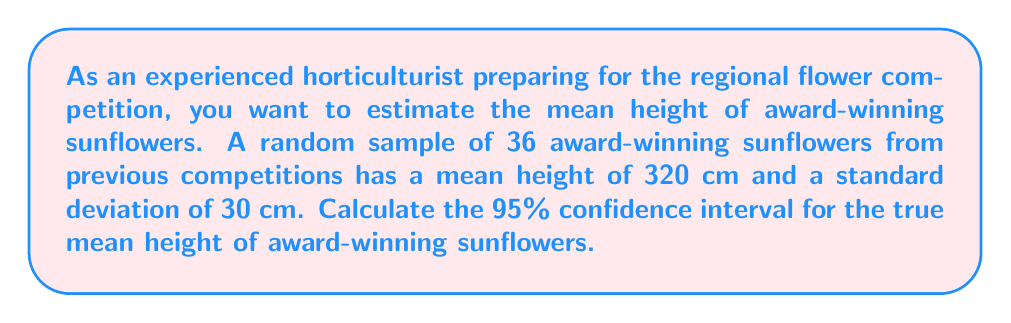What is the answer to this math problem? Let's calculate the confidence interval step-by-step:

1) The formula for the confidence interval is:

   $$\bar{x} \pm t_{\alpha/2} \cdot \frac{s}{\sqrt{n}}$$

   where $\bar{x}$ is the sample mean, $s$ is the sample standard deviation, $n$ is the sample size, and $t_{\alpha/2}$ is the t-value for the desired confidence level.

2) We know:
   - $\bar{x} = 320$ cm
   - $s = 30$ cm
   - $n = 36$
   - Confidence level = 95%, so $\alpha = 0.05$

3) For a 95% confidence interval with 35 degrees of freedom (n-1), the t-value is approximately 2.030.

4) Now, let's calculate the margin of error:

   $$\text{Margin of Error} = t_{\alpha/2} \cdot \frac{s}{\sqrt{n}} = 2.030 \cdot \frac{30}{\sqrt{36}} = 2.030 \cdot 5 = 10.15$$

5) The confidence interval is:

   $$320 \pm 10.15$$

6) Therefore, the 95% confidence interval is (309.85 cm, 330.15 cm).
Answer: (309.85 cm, 330.15 cm) 